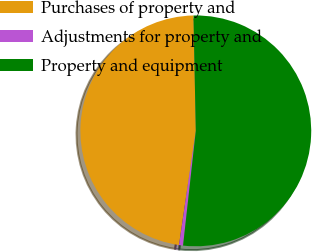Convert chart. <chart><loc_0><loc_0><loc_500><loc_500><pie_chart><fcel>Purchases of property and<fcel>Adjustments for property and<fcel>Property and equipment<nl><fcel>47.35%<fcel>0.57%<fcel>52.08%<nl></chart> 